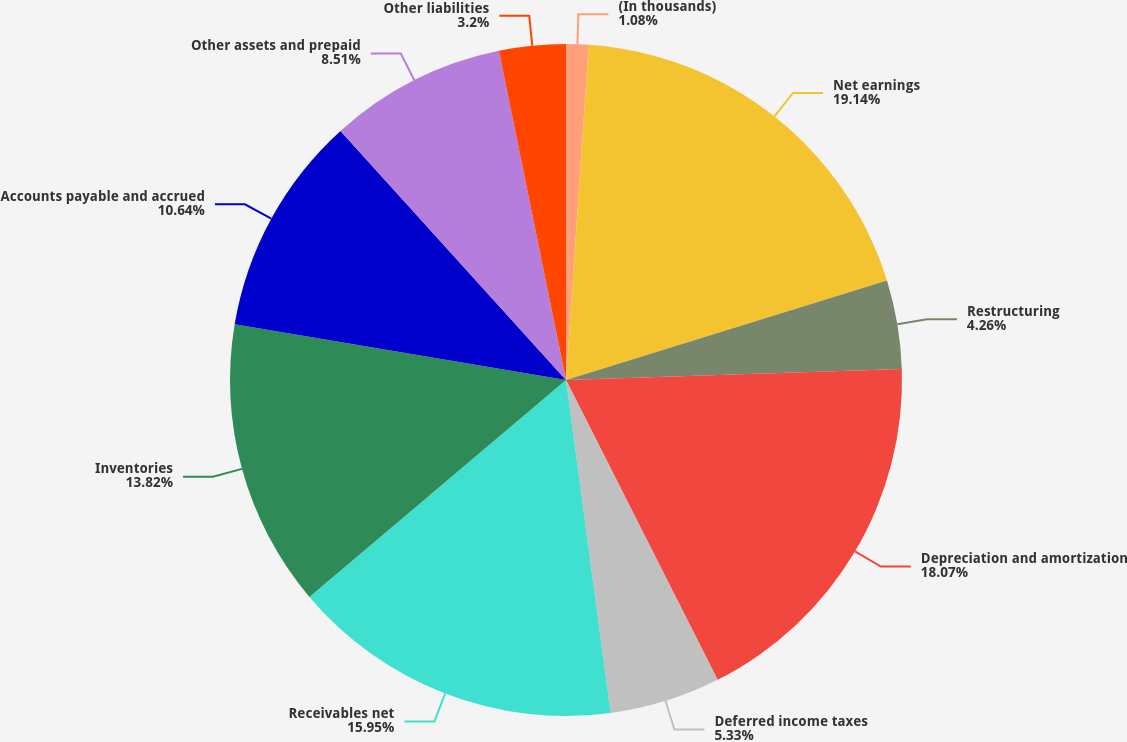Convert chart. <chart><loc_0><loc_0><loc_500><loc_500><pie_chart><fcel>(In thousands)<fcel>Net earnings<fcel>Restructuring<fcel>Depreciation and amortization<fcel>Deferred income taxes<fcel>Receivables net<fcel>Inventories<fcel>Accounts payable and accrued<fcel>Other assets and prepaid<fcel>Other liabilities<nl><fcel>1.08%<fcel>19.14%<fcel>4.26%<fcel>18.07%<fcel>5.33%<fcel>15.95%<fcel>13.82%<fcel>10.64%<fcel>8.51%<fcel>3.2%<nl></chart> 